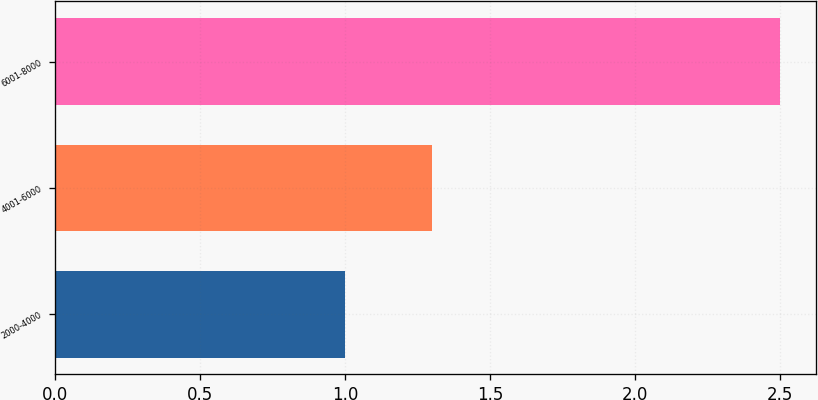<chart> <loc_0><loc_0><loc_500><loc_500><bar_chart><fcel>2000-4000<fcel>4001-6000<fcel>6001-8000<nl><fcel>1<fcel>1.3<fcel>2.5<nl></chart> 